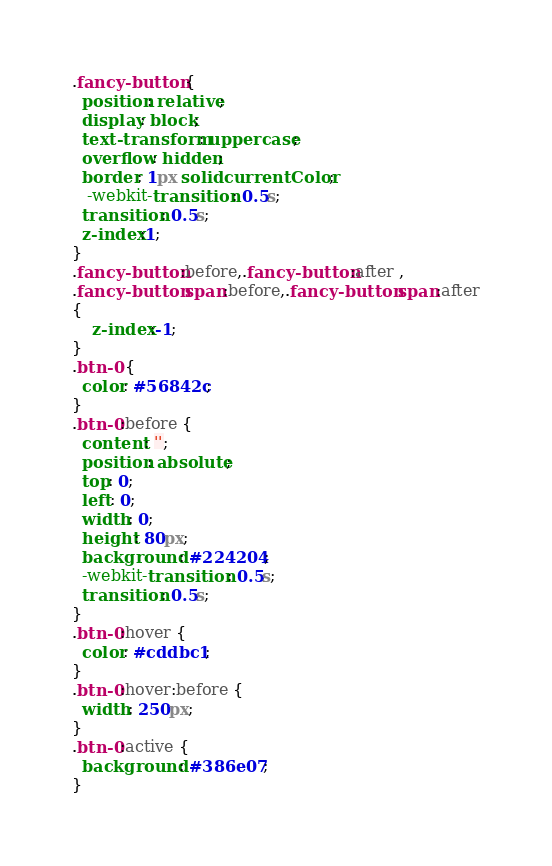<code> <loc_0><loc_0><loc_500><loc_500><_CSS_>.fancy-button {
  position: relative;
  display: block;
  text-transform: uppercase;
  overflow: hidden;
  border: 1px solid currentColor;
   -webkit-transition: 0.5s;
  transition: 0.5s;
  z-index:1;
}
.fancy-button:before,.fancy-button:after ,
.fancy-button span:before,.fancy-button span:after
{
	z-index:-1;
}
.btn-0 {
  color: #56842c;
}
.btn-0:before {
  content: '';
  position: absolute;
  top: 0;
  left: 0;
  width: 0;
  height: 80px;
  background: #224204;
  -webkit-transition: 0.5s;
  transition: 0.5s;
}
.btn-0:hover {
  color: #cddbc1;
}
.btn-0:hover:before {
  width: 250px;
}
.btn-0:active {
  background: #386e07;
}
</code> 